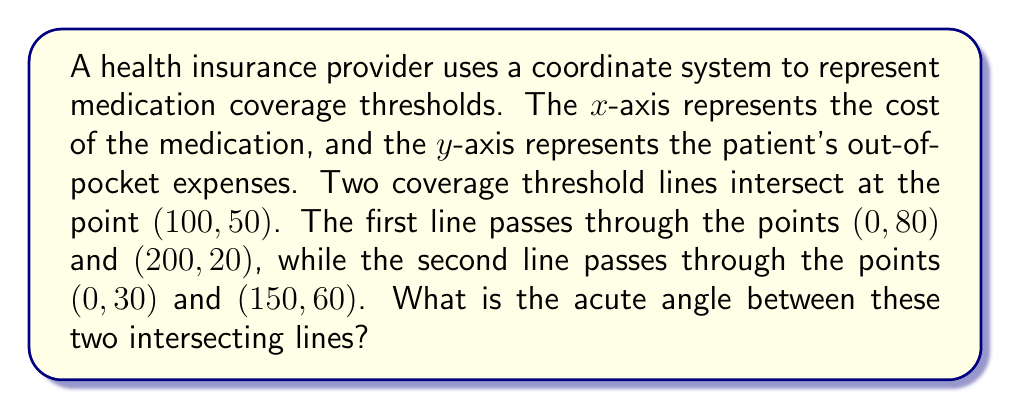Can you solve this math problem? To solve this problem, we need to follow these steps:

1. Find the slopes of both lines
2. Use the slopes to calculate the angle between the lines

Step 1: Finding the slopes

For line 1: $m_1 = \frac{y_2 - y_1}{x_2 - x_1} = \frac{20 - 80}{200 - 0} = -\frac{3}{10} = -0.3$

For line 2: $m_2 = \frac{y_2 - y_1}{x_2 - x_1} = \frac{60 - 30}{150 - 0} = \frac{1}{5} = 0.2$

Step 2: Calculating the angle

We can use the formula for the angle between two lines:

$$\tan \theta = \left|\frac{m_2 - m_1}{1 + m_1m_2}\right|$$

Substituting the values:

$$\tan \theta = \left|\frac{0.2 - (-0.3)}{1 + (-0.3)(0.2)}\right| = \left|\frac{0.5}{0.94}\right| \approx 0.5319$$

Now, we need to find the inverse tangent (arctan) of this value:

$$\theta = \arctan(0.5319) \approx 0.4894 \text{ radians}$$

Converting to degrees:

$$\theta \approx 0.4894 \times \frac{180}{\pi} \approx 28.04°$$

[asy]
import geometry;

size(200);
defaultpen(fontsize(10pt));

pair O=(0,0), A=(200,20), B=(0,80), C=(150,60), D=(0,30);
draw(B--A,blue);
draw(D--C,red);

dot("(100,50)",scale(0.7)*((100,50)),NE);
dot("(0,80)",scale(0.7)*B,NW);
dot("(200,20)",scale(0.7)*A,SE);
dot("(0,30)",scale(0.7)*D,NW);
dot("(150,60)",scale(0.7)*C,NE);

label("Cost of medication",scale(0.7)*(200,-10),S);
label("Patient's out-of-pocket expenses",scale(0.7)*(-10,80),W);

draw(scale(0.7)*arc((100,50),20,0,28.04),green);
label("28.04°",scale(0.7)*((120,60)),E,green);
[/asy]
Answer: The acute angle between the two intersecting lines representing insurance coverage thresholds is approximately $28.04°$. 